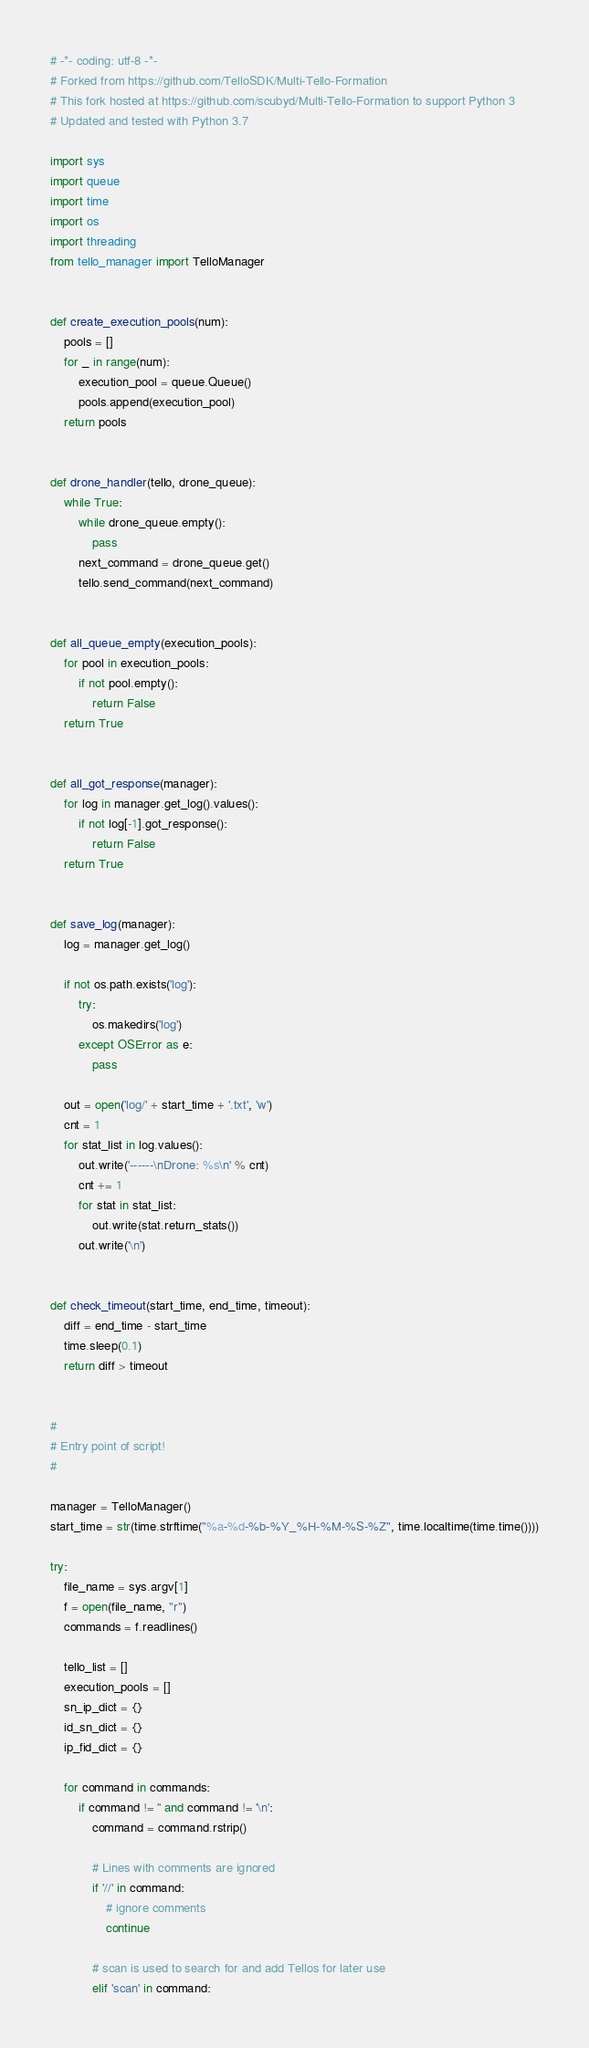<code> <loc_0><loc_0><loc_500><loc_500><_Python_># -*- coding: utf-8 -*-
# Forked from https://github.com/TelloSDK/Multi-Tello-Formation
# This fork hosted at https://github.com/scubyd/Multi-Tello-Formation to support Python 3
# Updated and tested with Python 3.7

import sys
import queue
import time
import os
import threading
from tello_manager import TelloManager


def create_execution_pools(num):
    pools = []
    for _ in range(num):
        execution_pool = queue.Queue()
        pools.append(execution_pool)
    return pools


def drone_handler(tello, drone_queue):
    while True:
        while drone_queue.empty():
            pass
        next_command = drone_queue.get()
        tello.send_command(next_command)


def all_queue_empty(execution_pools):
    for pool in execution_pools:
        if not pool.empty():
            return False
    return True


def all_got_response(manager):
    for log in manager.get_log().values():
        if not log[-1].got_response():
            return False
    return True


def save_log(manager):
    log = manager.get_log()

    if not os.path.exists('log'):
        try:
            os.makedirs('log')
        except OSError as e:
            pass

    out = open('log/' + start_time + '.txt', 'w')
    cnt = 1
    for stat_list in log.values():
        out.write('------\nDrone: %s\n' % cnt)
        cnt += 1
        for stat in stat_list:
            out.write(stat.return_stats())
        out.write('\n')


def check_timeout(start_time, end_time, timeout):
    diff = end_time - start_time
    time.sleep(0.1)
    return diff > timeout


#
# Entry point of script!
#

manager = TelloManager()
start_time = str(time.strftime("%a-%d-%b-%Y_%H-%M-%S-%Z", time.localtime(time.time())))

try:
    file_name = sys.argv[1]
    f = open(file_name, "r")
    commands = f.readlines()

    tello_list = []
    execution_pools = []
    sn_ip_dict = {}
    id_sn_dict = {}
    ip_fid_dict = {}

    for command in commands:
        if command != '' and command != '\n':
            command = command.rstrip()

            # Lines with comments are ignored
            if '//' in command:
                # ignore comments
                continue

            # scan is used to search for and add Tellos for later use
            elif 'scan' in command:</code> 